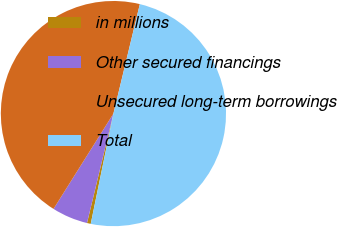<chart> <loc_0><loc_0><loc_500><loc_500><pie_chart><fcel>in millions<fcel>Other secured financings<fcel>Unsecured long-term borrowings<fcel>Total<nl><fcel>0.54%<fcel>5.16%<fcel>44.84%<fcel>49.46%<nl></chart> 